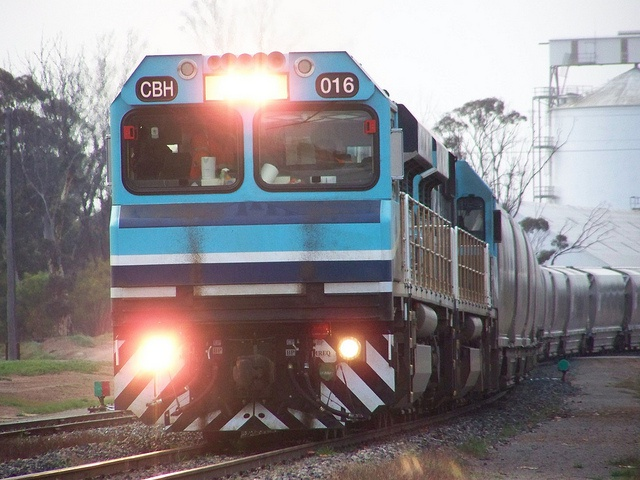Describe the objects in this image and their specific colors. I can see a train in white, gray, black, maroon, and darkgray tones in this image. 